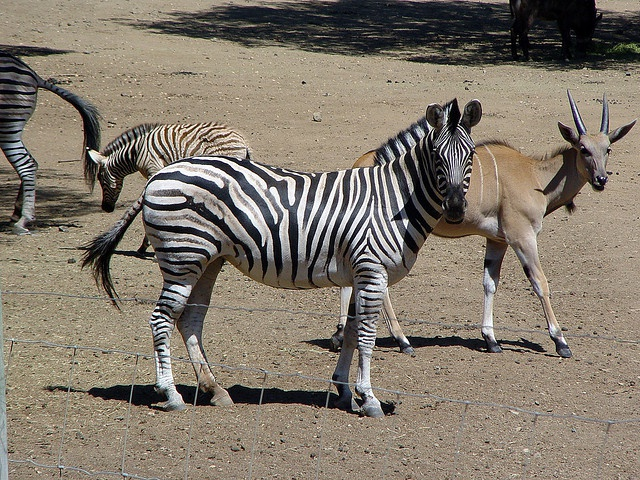Describe the objects in this image and their specific colors. I can see zebra in gray, black, lightgray, and darkgray tones, zebra in darkgray, black, and gray tones, and zebra in darkgray, black, lightgray, and gray tones in this image. 